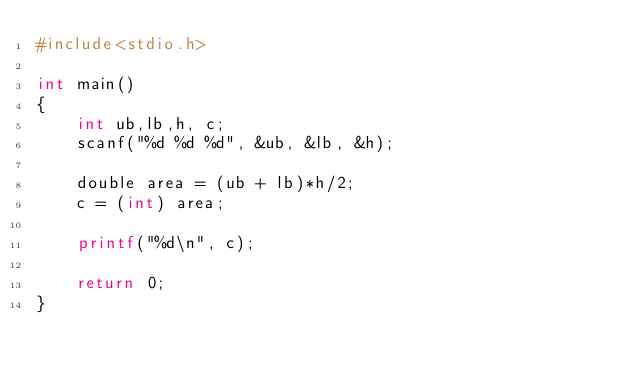Convert code to text. <code><loc_0><loc_0><loc_500><loc_500><_Awk_>#include<stdio.h>

int main()
{
    int ub,lb,h, c;
    scanf("%d %d %d", &ub, &lb, &h);

    double area = (ub + lb)*h/2;
    c = (int) area;

    printf("%d\n", c);

    return 0;
}</code> 